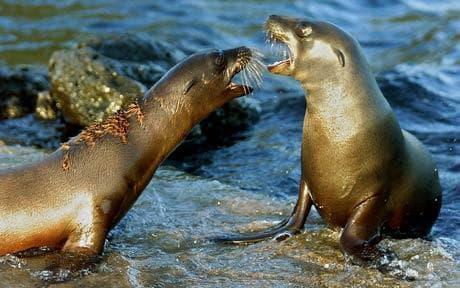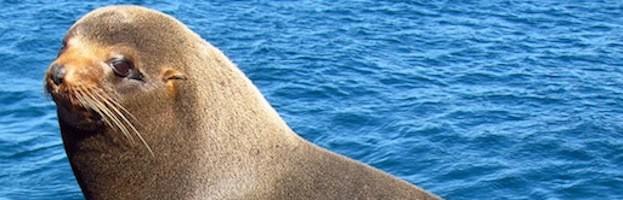The first image is the image on the left, the second image is the image on the right. Given the left and right images, does the statement "The left image contains exactly two seals." hold true? Answer yes or no. Yes. 